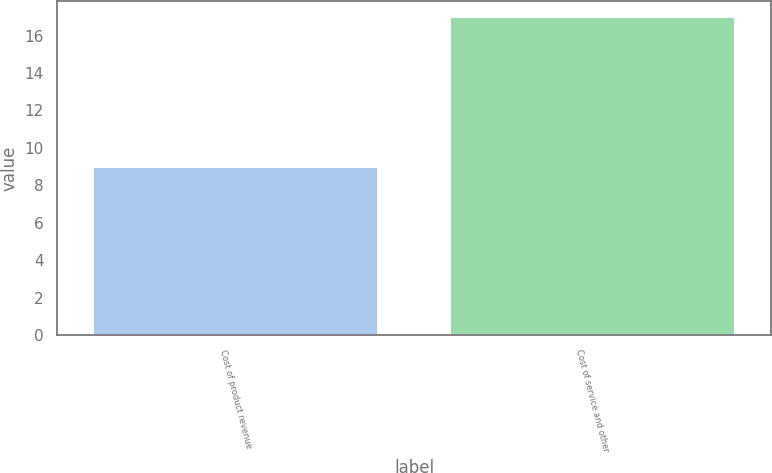<chart> <loc_0><loc_0><loc_500><loc_500><bar_chart><fcel>Cost of product revenue<fcel>Cost of service and other<nl><fcel>9<fcel>17<nl></chart> 